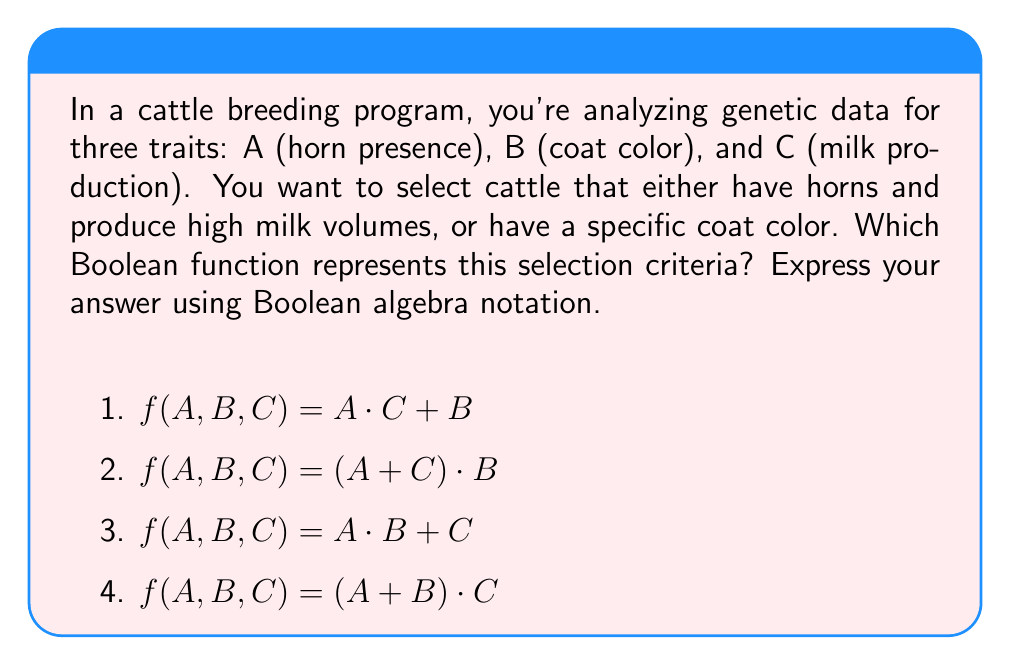Give your solution to this math problem. Let's break this down step-by-step:

1) First, let's identify what each variable represents:
   A: Horn presence (1 if present, 0 if absent)
   B: Specific coat color (1 if present, 0 if absent)
   C: High milk production (1 if high, 0 if low)

2) Now, let's analyze the selection criteria:
   - We want cattle that have horns AND produce high milk volumes
   - OR have a specific coat color

3) Let's translate this into Boolean algebra:
   - "Horns AND high milk production" is represented as $A \cdot C$
   - "OR specific coat color" is represented by adding B

4) Combining these, we get: $A \cdot C + B$

5) This matches option 1 in the given choices: $f(A,B,C) = A \cdot C + B$

6) Let's verify why the other options are incorrect:
   - Option 2: $(A + C) \cdot B$ would select cattle with the specific coat color AND either horns or high milk production, which is not what we want.
   - Option 3: $A \cdot B + C$ would select cattle with horns and the specific coat color, OR high milk production, which doesn't match our criteria.
   - Option 4: $(A + B) \cdot C$ would select cattle with high milk production AND either horns or the specific coat color, which is also incorrect.

Therefore, the correct Boolean function is $f(A,B,C) = A \cdot C + B$.
Answer: $f(A,B,C) = A \cdot C + B$ 